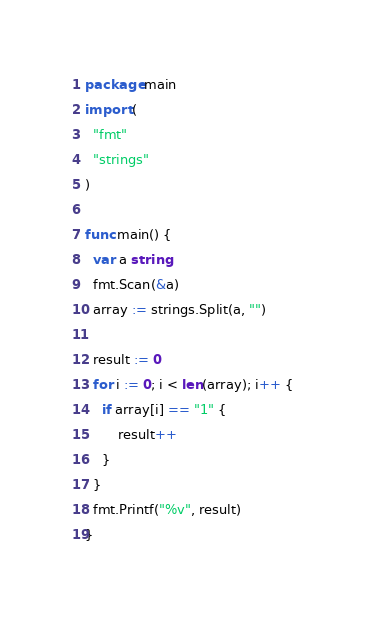<code> <loc_0><loc_0><loc_500><loc_500><_Go_>package main
import (
  "fmt"
  "strings"
)

func main() {
  var a string
  fmt.Scan(&a)
  array := strings.Split(a, "")
  
  result := 0
  for i := 0; i < len(array); i++ {
    if array[i] == "1" {
    	result++
    }
  }
  fmt.Printf("%v", result)
}</code> 